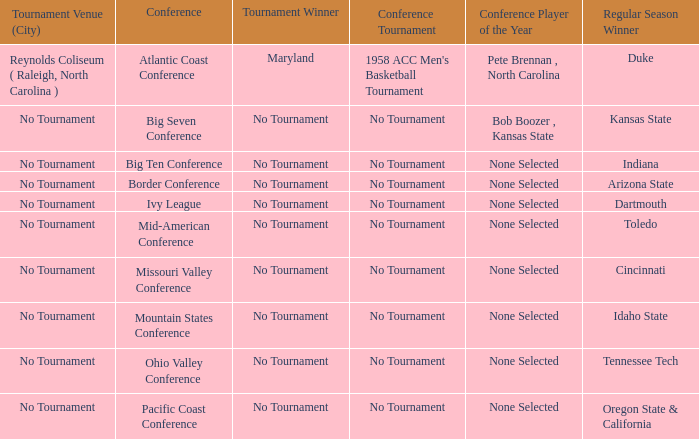Who won the tournament when Idaho State won the regular season? No Tournament. 